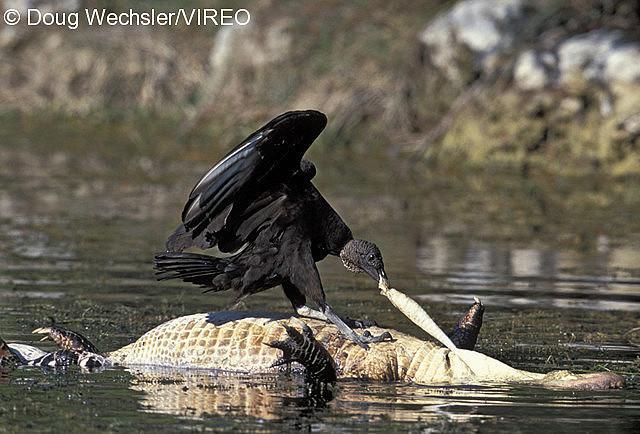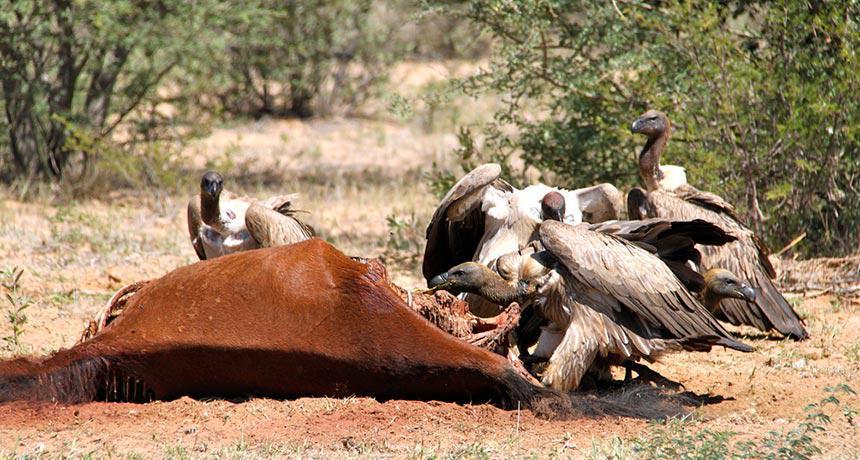The first image is the image on the left, the second image is the image on the right. Evaluate the accuracy of this statement regarding the images: "At least one of the images only has one bird standing on a dead animal.". Is it true? Answer yes or no. Yes. The first image is the image on the left, the second image is the image on the right. Analyze the images presented: Is the assertion "In one of the images, a lone bird is seen at the body of a dead animal." valid? Answer yes or no. Yes. 